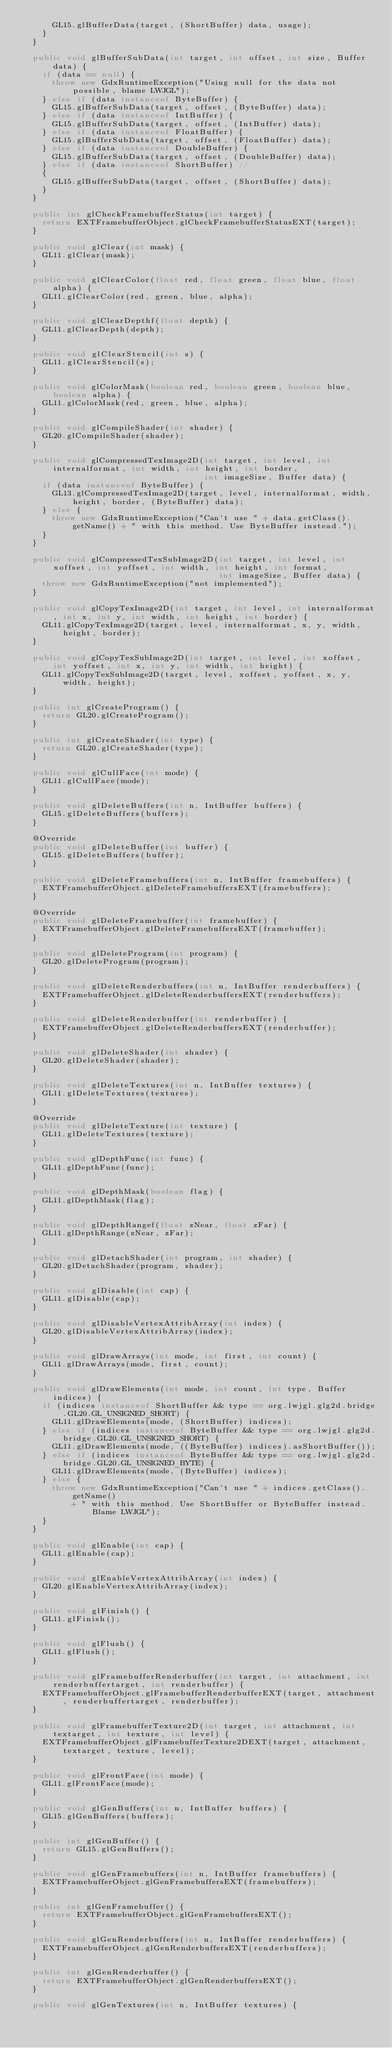<code> <loc_0><loc_0><loc_500><loc_500><_Java_>      GL15.glBufferData(target, (ShortBuffer) data, usage);
    }
  }

  public void glBufferSubData(int target, int offset, int size, Buffer data) {
    if (data == null) {
      throw new GdxRuntimeException("Using null for the data not possible, blame LWJGL");
    } else if (data instanceof ByteBuffer) {
      GL15.glBufferSubData(target, offset, (ByteBuffer) data);
    } else if (data instanceof IntBuffer) {
      GL15.glBufferSubData(target, offset, (IntBuffer) data);
    } else if (data instanceof FloatBuffer) {
      GL15.glBufferSubData(target, offset, (FloatBuffer) data);
    } else if (data instanceof DoubleBuffer) {
      GL15.glBufferSubData(target, offset, (DoubleBuffer) data);
    } else if (data instanceof ShortBuffer) //
    {
      GL15.glBufferSubData(target, offset, (ShortBuffer) data);
    }
  }

  public int glCheckFramebufferStatus(int target) {
    return EXTFramebufferObject.glCheckFramebufferStatusEXT(target);
  }

  public void glClear(int mask) {
    GL11.glClear(mask);
  }

  public void glClearColor(float red, float green, float blue, float alpha) {
    GL11.glClearColor(red, green, blue, alpha);
  }

  public void glClearDepthf(float depth) {
    GL11.glClearDepth(depth);
  }

  public void glClearStencil(int s) {
    GL11.glClearStencil(s);
  }

  public void glColorMask(boolean red, boolean green, boolean blue, boolean alpha) {
    GL11.glColorMask(red, green, blue, alpha);
  }

  public void glCompileShader(int shader) {
    GL20.glCompileShader(shader);
  }

  public void glCompressedTexImage2D(int target, int level, int internalformat, int width, int height, int border,
                                     int imageSize, Buffer data) {
    if (data instanceof ByteBuffer) {
      GL13.glCompressedTexImage2D(target, level, internalformat, width, height, border, (ByteBuffer) data);
    } else {
      throw new GdxRuntimeException("Can't use " + data.getClass().getName() + " with this method. Use ByteBuffer instead.");
    }
  }

  public void glCompressedTexSubImage2D(int target, int level, int xoffset, int yoffset, int width, int height, int format,
                                        int imageSize, Buffer data) {
    throw new GdxRuntimeException("not implemented");
  }

  public void glCopyTexImage2D(int target, int level, int internalformat, int x, int y, int width, int height, int border) {
    GL11.glCopyTexImage2D(target, level, internalformat, x, y, width, height, border);
  }

  public void glCopyTexSubImage2D(int target, int level, int xoffset, int yoffset, int x, int y, int width, int height) {
    GL11.glCopyTexSubImage2D(target, level, xoffset, yoffset, x, y, width, height);
  }

  public int glCreateProgram() {
    return GL20.glCreateProgram();
  }

  public int glCreateShader(int type) {
    return GL20.glCreateShader(type);
  }

  public void glCullFace(int mode) {
    GL11.glCullFace(mode);
  }

  public void glDeleteBuffers(int n, IntBuffer buffers) {
    GL15.glDeleteBuffers(buffers);
  }

  @Override
  public void glDeleteBuffer(int buffer) {
    GL15.glDeleteBuffers(buffer);
  }

  public void glDeleteFramebuffers(int n, IntBuffer framebuffers) {
    EXTFramebufferObject.glDeleteFramebuffersEXT(framebuffers);
  }

  @Override
  public void glDeleteFramebuffer(int framebuffer) {
    EXTFramebufferObject.glDeleteFramebuffersEXT(framebuffer);
  }

  public void glDeleteProgram(int program) {
    GL20.glDeleteProgram(program);
  }

  public void glDeleteRenderbuffers(int n, IntBuffer renderbuffers) {
    EXTFramebufferObject.glDeleteRenderbuffersEXT(renderbuffers);
  }

  public void glDeleteRenderbuffer(int renderbuffer) {
    EXTFramebufferObject.glDeleteRenderbuffersEXT(renderbuffer);
  }

  public void glDeleteShader(int shader) {
    GL20.glDeleteShader(shader);
  }

  public void glDeleteTextures(int n, IntBuffer textures) {
    GL11.glDeleteTextures(textures);
  }

  @Override
  public void glDeleteTexture(int texture) {
    GL11.glDeleteTextures(texture);
  }

  public void glDepthFunc(int func) {
    GL11.glDepthFunc(func);
  }

  public void glDepthMask(boolean flag) {
    GL11.glDepthMask(flag);
  }

  public void glDepthRangef(float zNear, float zFar) {
    GL11.glDepthRange(zNear, zFar);
  }

  public void glDetachShader(int program, int shader) {
    GL20.glDetachShader(program, shader);
  }

  public void glDisable(int cap) {
    GL11.glDisable(cap);
  }

  public void glDisableVertexAttribArray(int index) {
    GL20.glDisableVertexAttribArray(index);
  }

  public void glDrawArrays(int mode, int first, int count) {
    GL11.glDrawArrays(mode, first, count);
  }

  public void glDrawElements(int mode, int count, int type, Buffer indices) {
    if (indices instanceof ShortBuffer && type == org.lwjgl.glg2d.bridge.GL20.GL_UNSIGNED_SHORT) {
      GL11.glDrawElements(mode, (ShortBuffer) indices);
    } else if (indices instanceof ByteBuffer && type == org.lwjgl.glg2d.bridge.GL20.GL_UNSIGNED_SHORT) {
      GL11.glDrawElements(mode, ((ByteBuffer) indices).asShortBuffer());
    } else if (indices instanceof ByteBuffer && type == org.lwjgl.glg2d.bridge.GL20.GL_UNSIGNED_BYTE) {
      GL11.glDrawElements(mode, (ByteBuffer) indices);
    } else {
      throw new GdxRuntimeException("Can't use " + indices.getClass().getName()
          + " with this method. Use ShortBuffer or ByteBuffer instead. Blame LWJGL");
    }
  }

  public void glEnable(int cap) {
    GL11.glEnable(cap);
  }

  public void glEnableVertexAttribArray(int index) {
    GL20.glEnableVertexAttribArray(index);
  }

  public void glFinish() {
    GL11.glFinish();
  }

  public void glFlush() {
    GL11.glFlush();
  }

  public void glFramebufferRenderbuffer(int target, int attachment, int renderbuffertarget, int renderbuffer) {
    EXTFramebufferObject.glFramebufferRenderbufferEXT(target, attachment, renderbuffertarget, renderbuffer);
  }

  public void glFramebufferTexture2D(int target, int attachment, int textarget, int texture, int level) {
    EXTFramebufferObject.glFramebufferTexture2DEXT(target, attachment, textarget, texture, level);
  }

  public void glFrontFace(int mode) {
    GL11.glFrontFace(mode);
  }

  public void glGenBuffers(int n, IntBuffer buffers) {
    GL15.glGenBuffers(buffers);
  }

  public int glGenBuffer() {
    return GL15.glGenBuffers();
  }

  public void glGenFramebuffers(int n, IntBuffer framebuffers) {
    EXTFramebufferObject.glGenFramebuffersEXT(framebuffers);
  }

  public int glGenFramebuffer() {
    return EXTFramebufferObject.glGenFramebuffersEXT();
  }

  public void glGenRenderbuffers(int n, IntBuffer renderbuffers) {
    EXTFramebufferObject.glGenRenderbuffersEXT(renderbuffers);
  }

  public int glGenRenderbuffer() {
    return EXTFramebufferObject.glGenRenderbuffersEXT();
  }

  public void glGenTextures(int n, IntBuffer textures) {</code> 